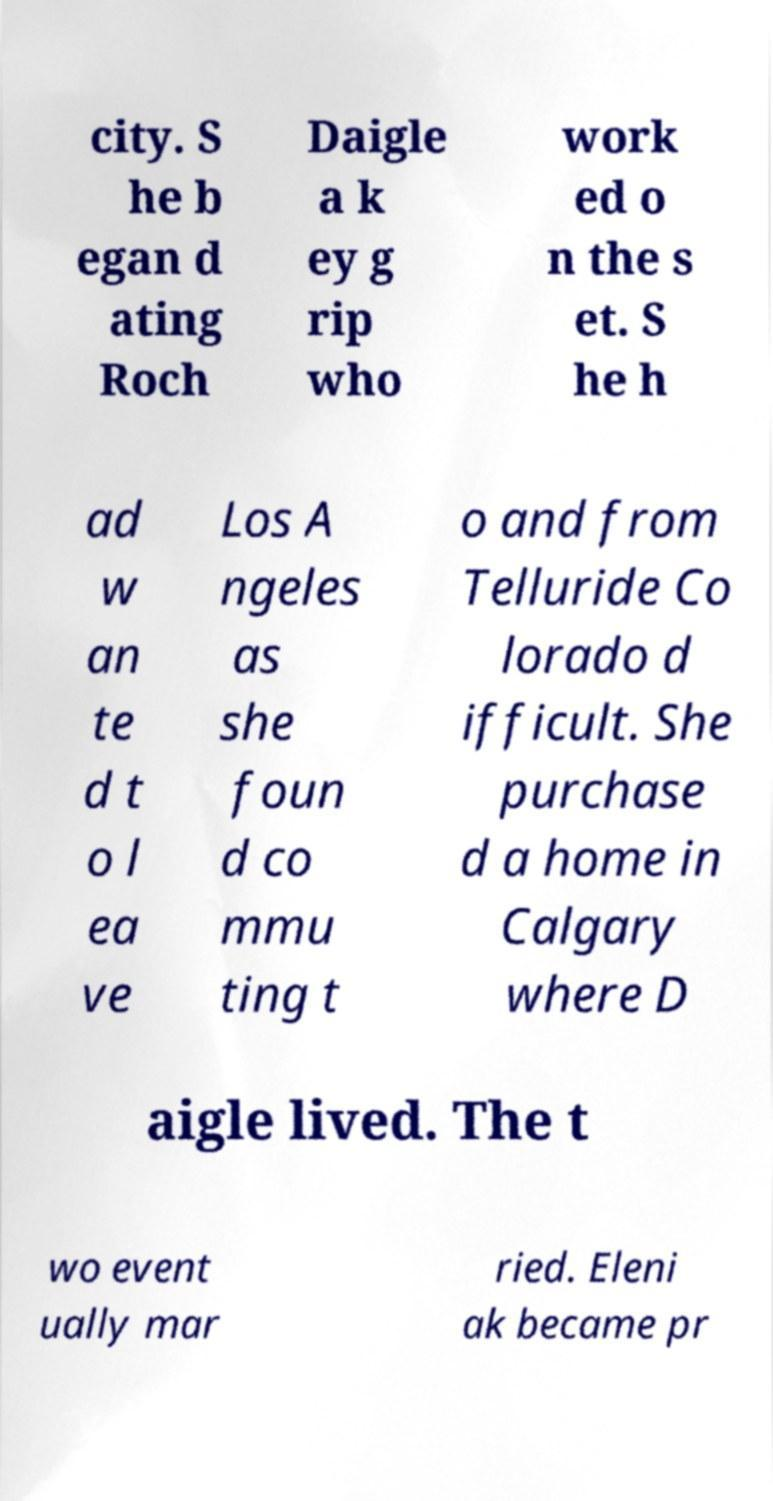I need the written content from this picture converted into text. Can you do that? city. S he b egan d ating Roch Daigle a k ey g rip who work ed o n the s et. S he h ad w an te d t o l ea ve Los A ngeles as she foun d co mmu ting t o and from Telluride Co lorado d ifficult. She purchase d a home in Calgary where D aigle lived. The t wo event ually mar ried. Eleni ak became pr 